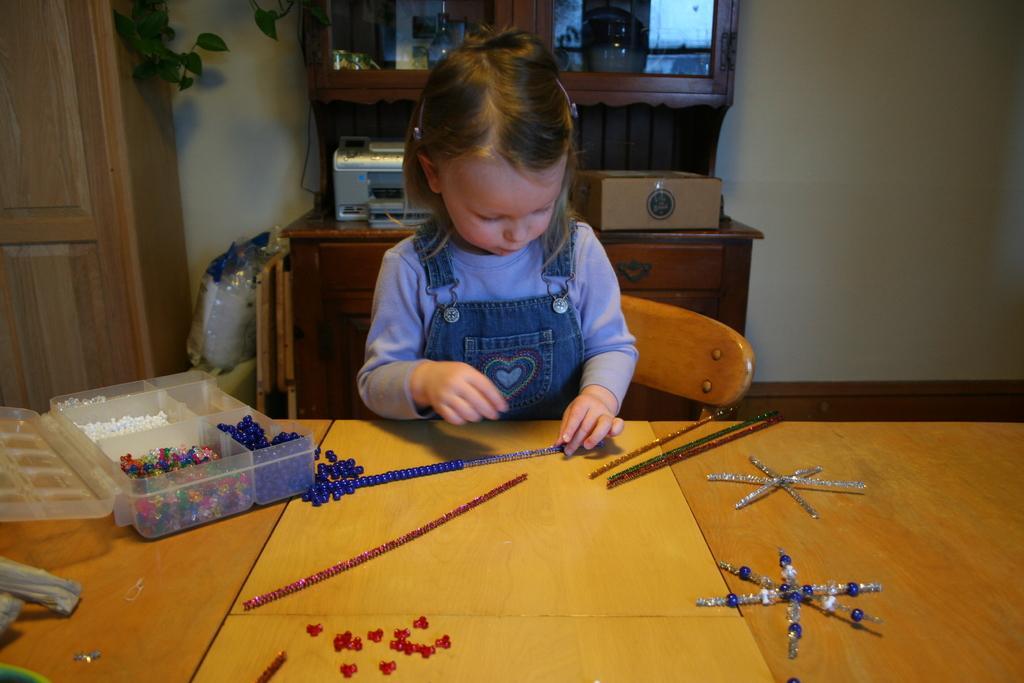In one or two sentences, can you explain what this image depicts? As we can see in the image there is a wall, table, chair and a girl standing over here. 